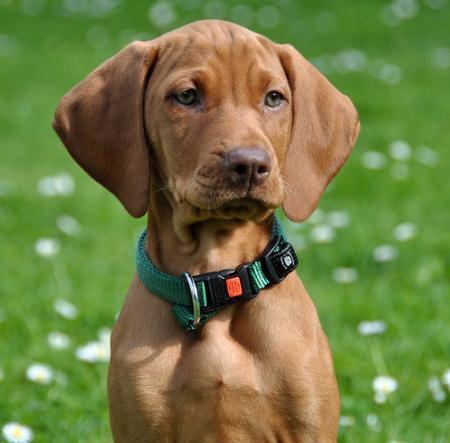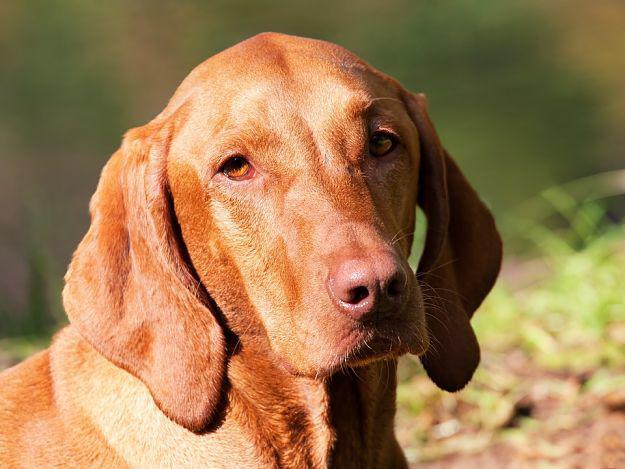The first image is the image on the left, the second image is the image on the right. Given the left and right images, does the statement "There are two brown dogs in collars." hold true? Answer yes or no. No. The first image is the image on the left, the second image is the image on the right. Considering the images on both sides, is "Both dogs are wearing collars." valid? Answer yes or no. No. 